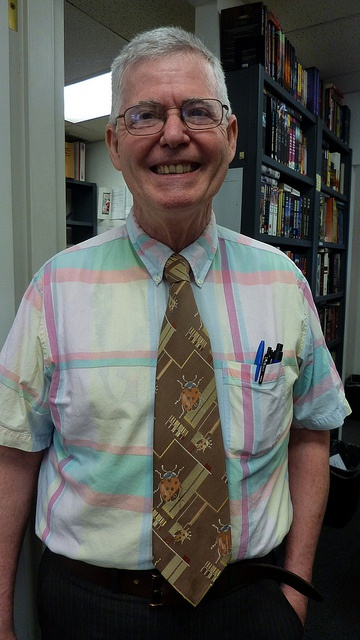Describe the objects in this image and their specific colors. I can see people in gray, darkgray, black, and maroon tones, tie in gray and black tones, book in gray, black, darkgreen, and navy tones, book in black and gray tones, and book in gray, black, maroon, and darkgreen tones in this image. 